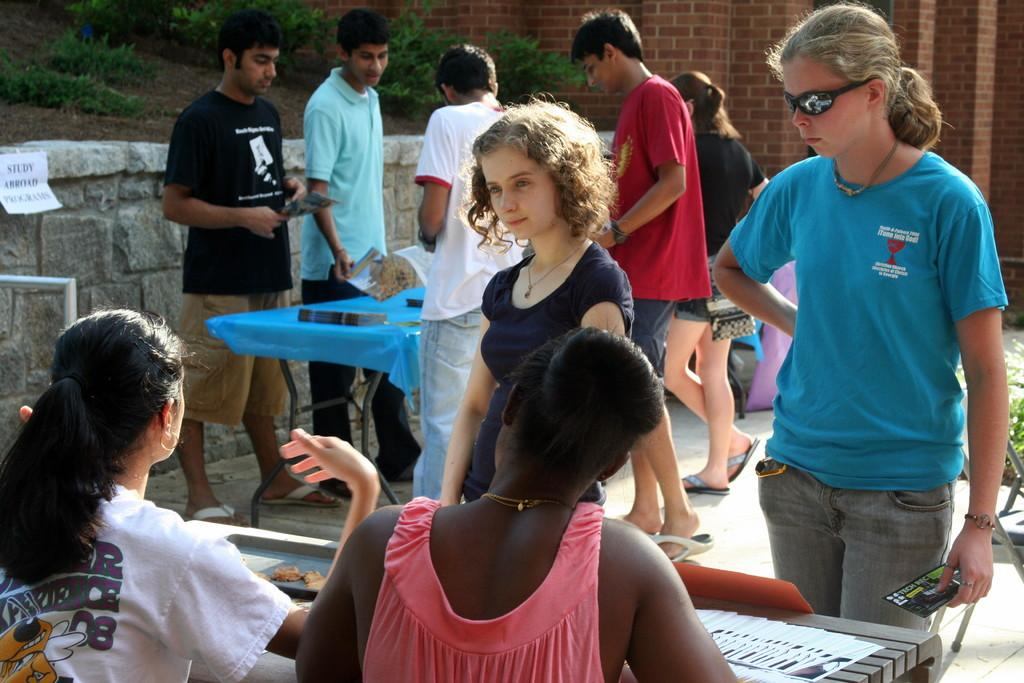What type of structure is visible in the image? There is a brick wall in the image. Who or what can be seen in the image besides the brick wall? There are people standing in the image. What piece of furniture is present in the image? There is a table in the image. What type of wire is being used by the toad in the image? There is no toad or wire present in the image. 